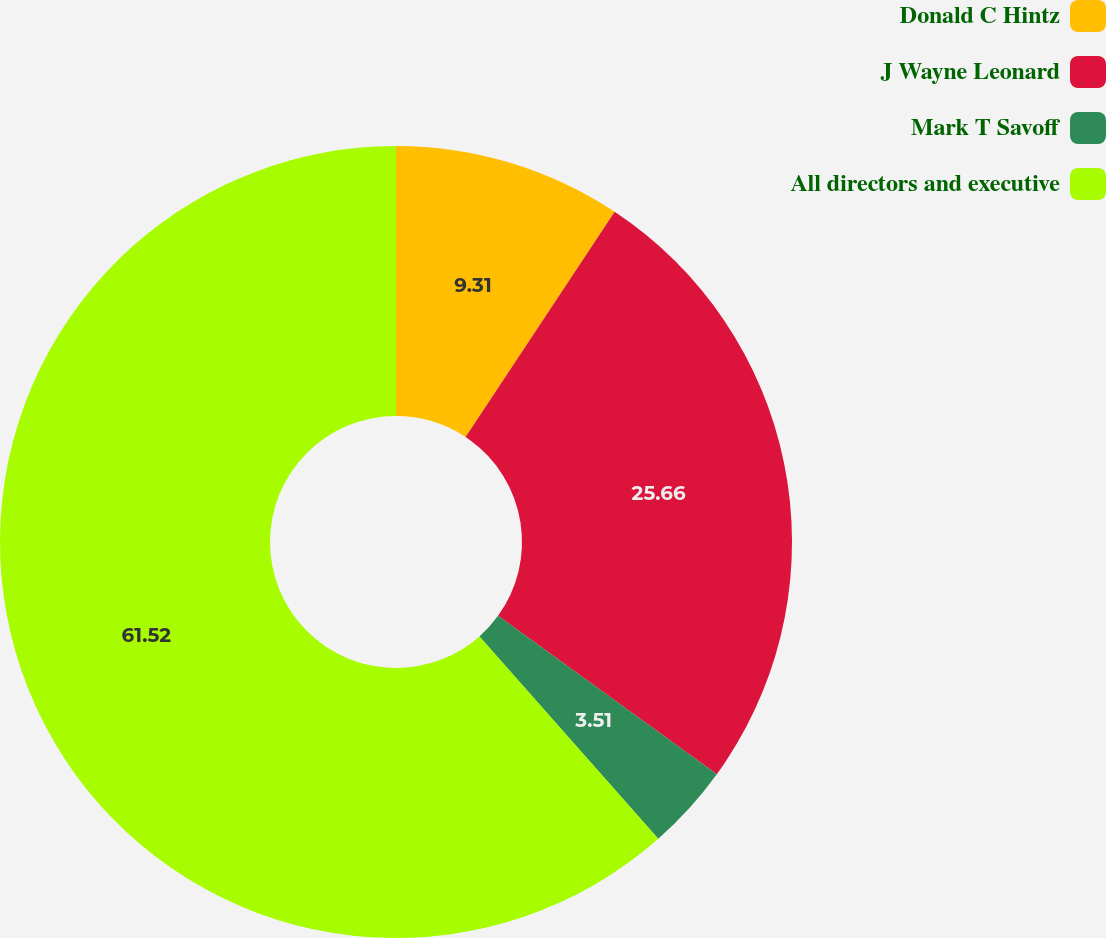Convert chart. <chart><loc_0><loc_0><loc_500><loc_500><pie_chart><fcel>Donald C Hintz<fcel>J Wayne Leonard<fcel>Mark T Savoff<fcel>All directors and executive<nl><fcel>9.31%<fcel>25.66%<fcel>3.51%<fcel>61.52%<nl></chart> 